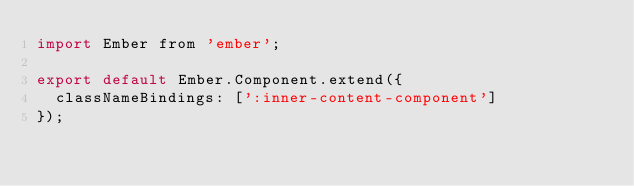Convert code to text. <code><loc_0><loc_0><loc_500><loc_500><_JavaScript_>import Ember from 'ember';

export default Ember.Component.extend({
  classNameBindings: [':inner-content-component']
});
</code> 